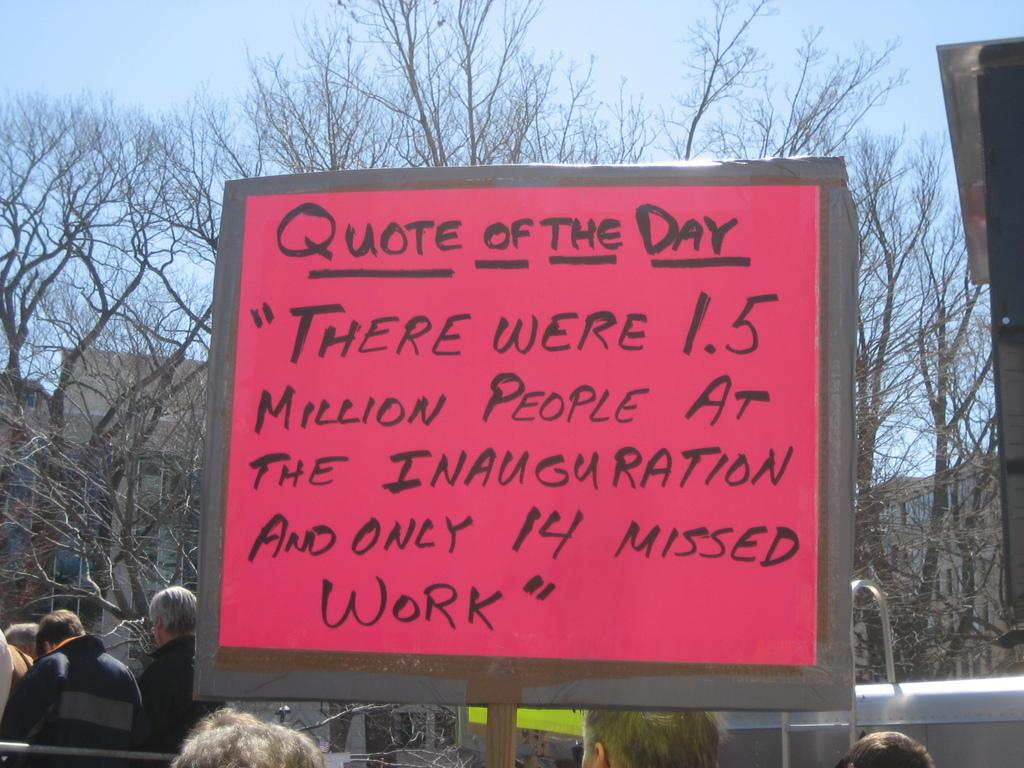What is the main object in the center of the image? There is a placard in the center of the image. Who or what can be seen at the bottom of the image? There are people at the bottom of the image. What type of natural scenery is visible in the background of the image? There are trees in the background of the image. What type of man-made structures can be seen in the background of the image? There are buildings in the background of the image. What part of the natural environment is visible in the background of the image? The sky is visible in the background of the image. What verse is being recited by the people at the bottom of the image? There is no indication in the image that the people are reciting a verse, so it cannot be determined from the picture. 